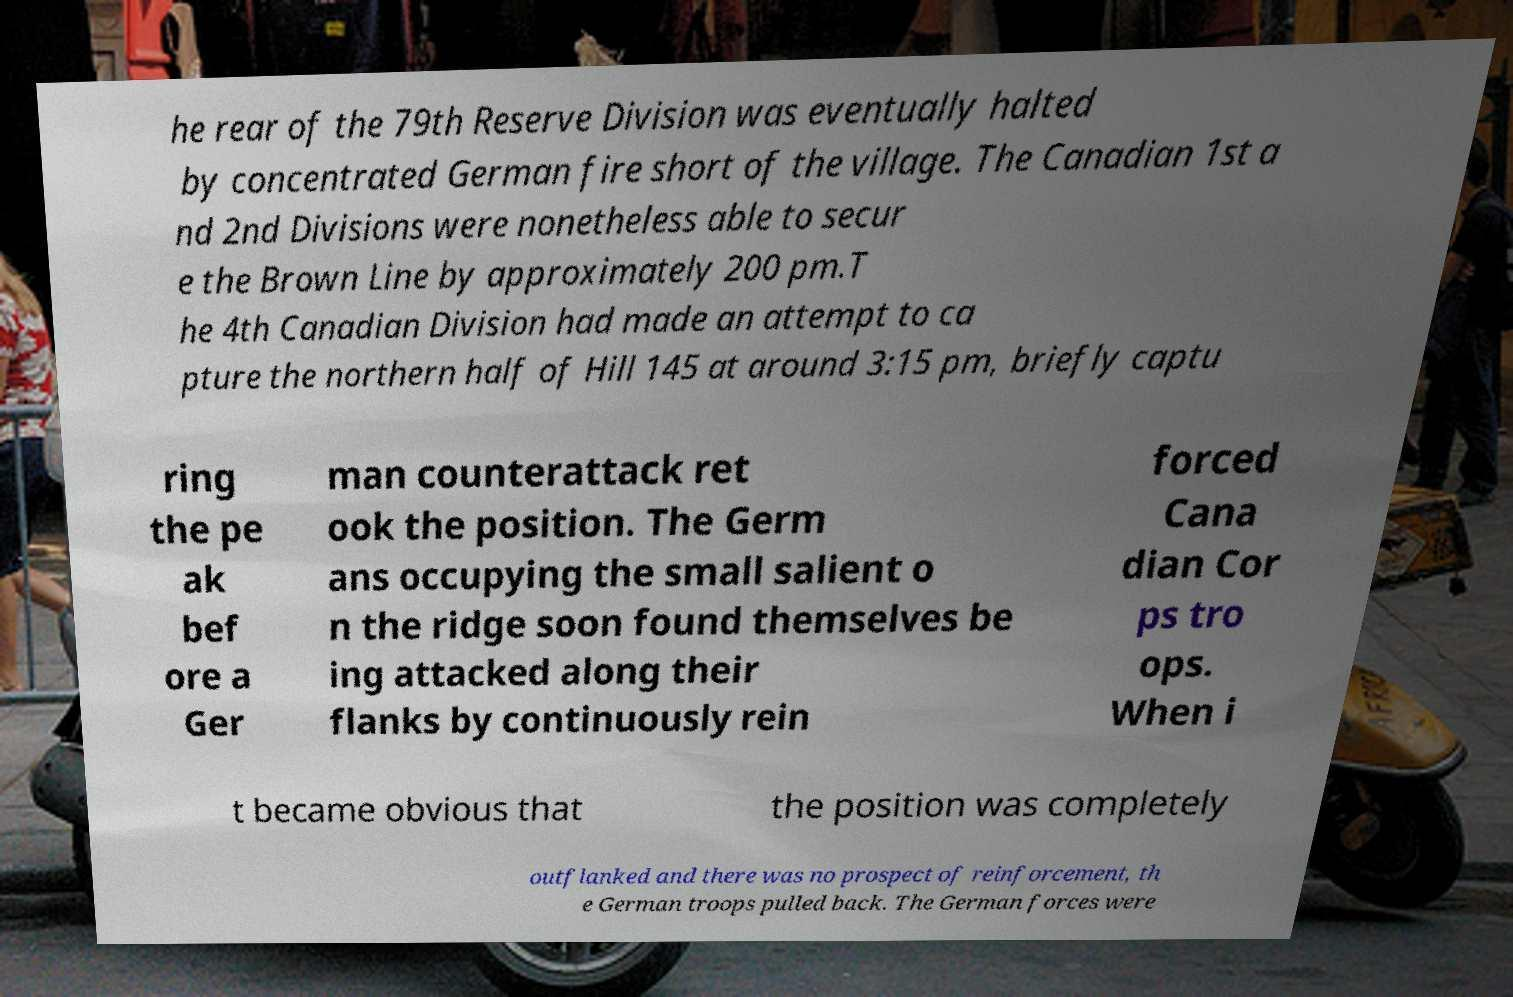Could you extract and type out the text from this image? he rear of the 79th Reserve Division was eventually halted by concentrated German fire short of the village. The Canadian 1st a nd 2nd Divisions were nonetheless able to secur e the Brown Line by approximately 200 pm.T he 4th Canadian Division had made an attempt to ca pture the northern half of Hill 145 at around 3:15 pm, briefly captu ring the pe ak bef ore a Ger man counterattack ret ook the position. The Germ ans occupying the small salient o n the ridge soon found themselves be ing attacked along their flanks by continuously rein forced Cana dian Cor ps tro ops. When i t became obvious that the position was completely outflanked and there was no prospect of reinforcement, th e German troops pulled back. The German forces were 